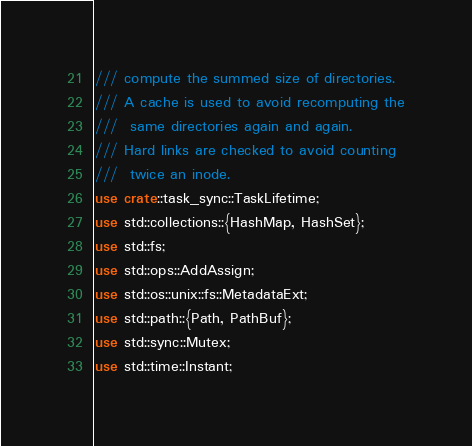Convert code to text. <code><loc_0><loc_0><loc_500><loc_500><_Rust_>/// compute the summed size of directories.
/// A cache is used to avoid recomputing the
///  same directories again and again.
/// Hard links are checked to avoid counting
///  twice an inode.
use crate::task_sync::TaskLifetime;
use std::collections::{HashMap, HashSet};
use std::fs;
use std::ops::AddAssign;
use std::os::unix::fs::MetadataExt;
use std::path::{Path, PathBuf};
use std::sync::Mutex;
use std::time::Instant;
</code> 